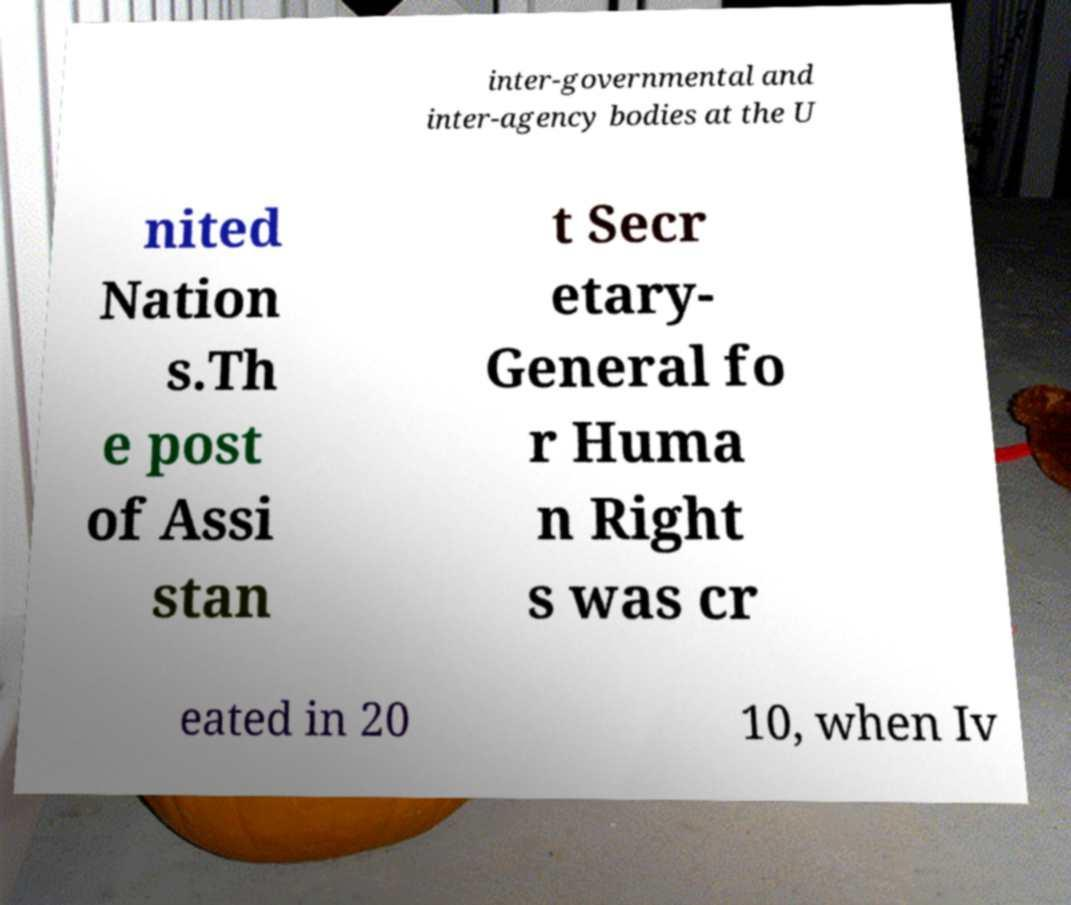I need the written content from this picture converted into text. Can you do that? inter-governmental and inter-agency bodies at the U nited Nation s.Th e post of Assi stan t Secr etary- General fo r Huma n Right s was cr eated in 20 10, when Iv 